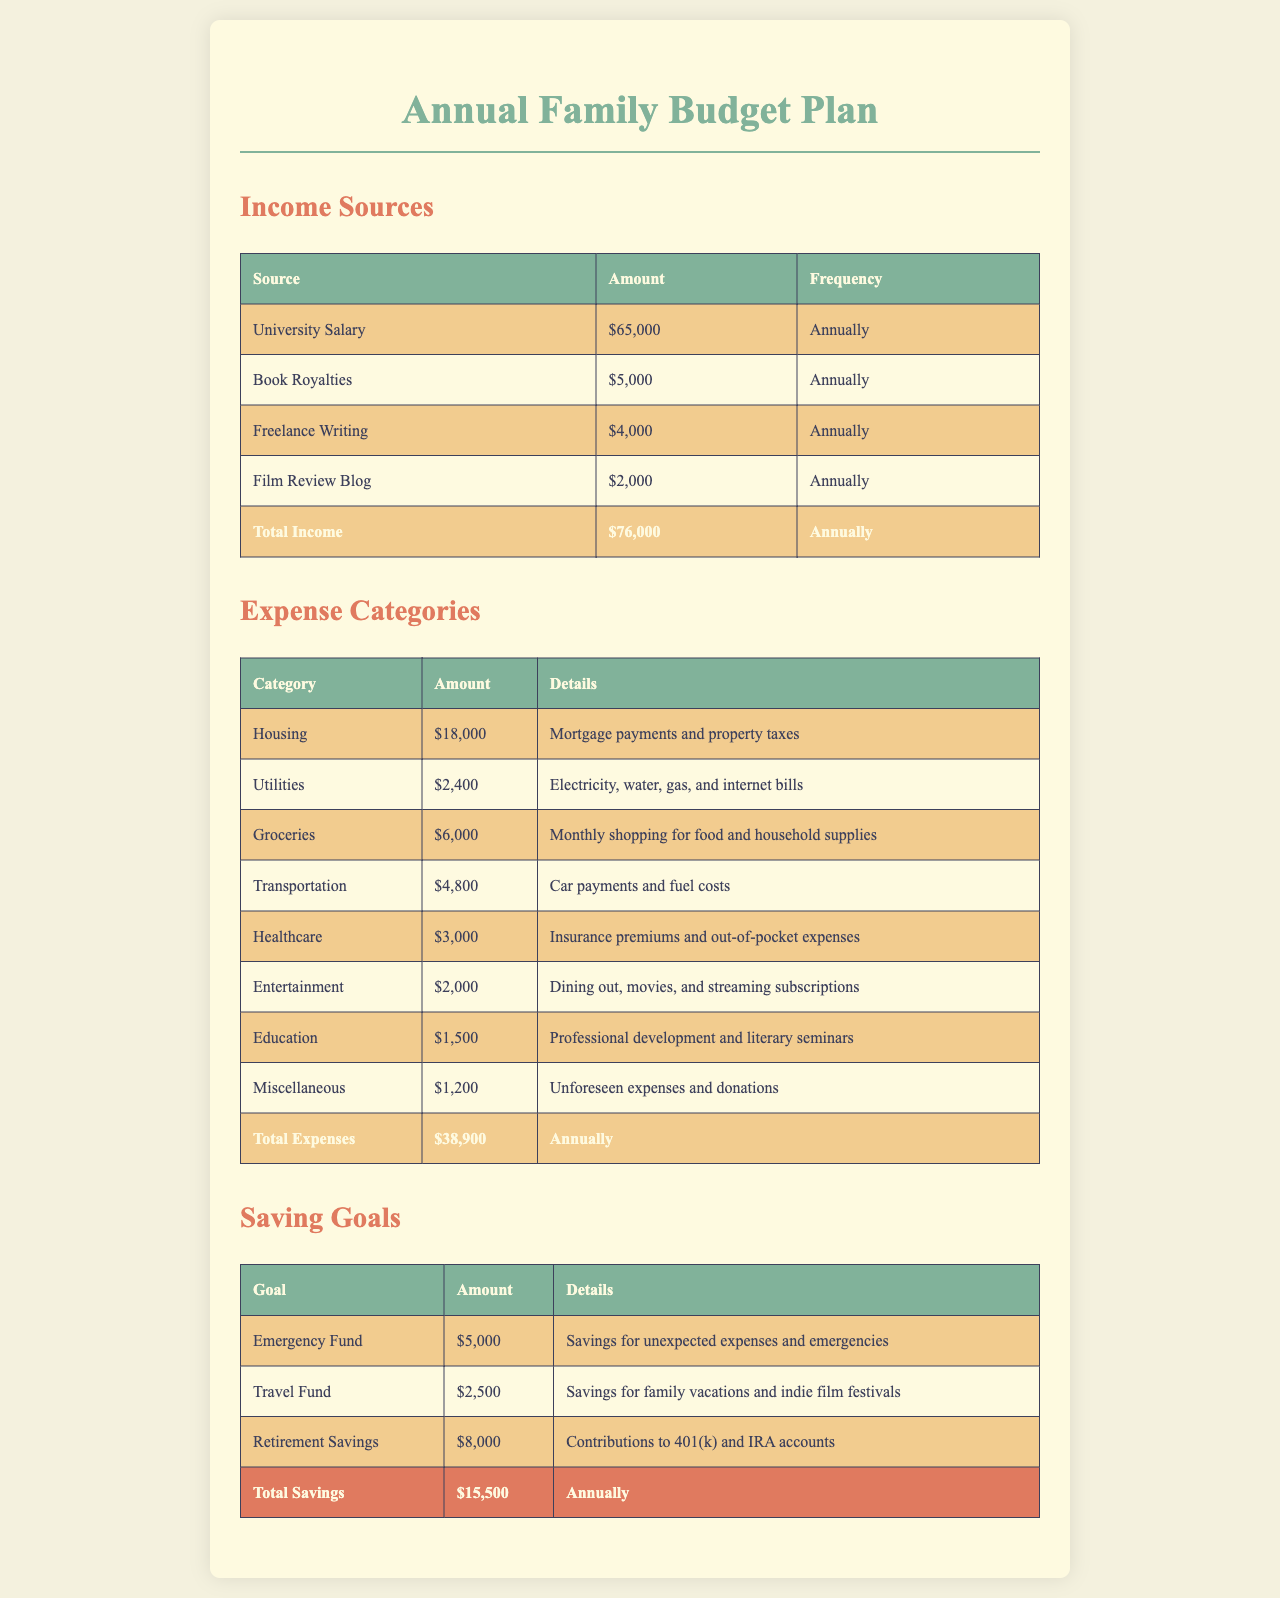What is the total income? The total income is the sum of all income sources listed in the document, which amounts to $65,000 + $5,000 + $4,000 + $2,000 = $76,000.
Answer: $76,000 How much was allocated for groceries? The amount allocated for groceries is specified in the expense categories section, which lists the expense as $6,000.
Answer: $6,000 What is the saving goal for the travel fund? The document states that the saving goal for the travel fund is $2,500 as detailed in the saving goals section.
Answer: $2,500 Which category has the highest expense? By comparing the amounts listed under each expense category, housing has the highest expense at $18,000.
Answer: Housing How much is allocated for entertainment? The expense allocated for entertainment is $2,000 as provided in the expense categories.
Answer: $2,000 What is the total amount of savings planned? The total savings is the sum of all saving goals outlined, which is $5,000 + $2,500 + $8,000 = $15,500.
Answer: $15,500 How frequently is the university salary received? The frequency of the university salary is stated as annually in the income sources section.
Answer: Annually What are the utility costs annually? The document lists the annual utility costs under the expense categories and indicates they total $2,400.
Answer: $2,400 How much is reserved for retirement savings? The saving goal for retirement savings is detailed in the saving goals section as $8,000.
Answer: $8,000 